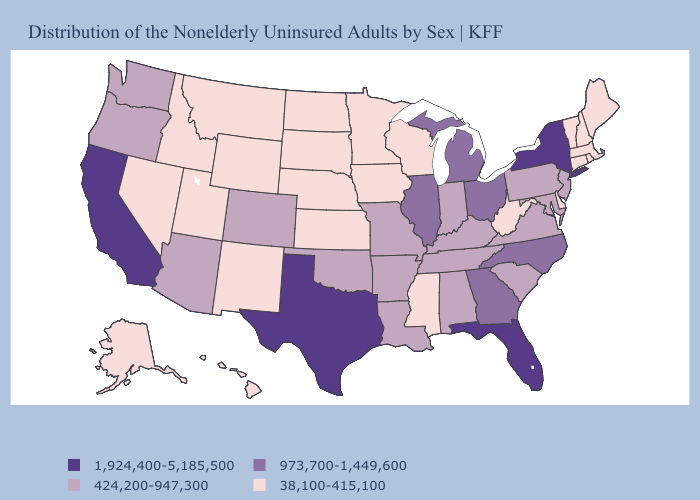Which states have the highest value in the USA?
Quick response, please. California, Florida, New York, Texas. Does Vermont have a lower value than New Hampshire?
Write a very short answer. No. Name the states that have a value in the range 38,100-415,100?
Keep it brief. Alaska, Connecticut, Delaware, Hawaii, Idaho, Iowa, Kansas, Maine, Massachusetts, Minnesota, Mississippi, Montana, Nebraska, Nevada, New Hampshire, New Mexico, North Dakota, Rhode Island, South Dakota, Utah, Vermont, West Virginia, Wisconsin, Wyoming. Does the first symbol in the legend represent the smallest category?
Be succinct. No. What is the value of Nebraska?
Be succinct. 38,100-415,100. Name the states that have a value in the range 424,200-947,300?
Keep it brief. Alabama, Arizona, Arkansas, Colorado, Indiana, Kentucky, Louisiana, Maryland, Missouri, New Jersey, Oklahoma, Oregon, Pennsylvania, South Carolina, Tennessee, Virginia, Washington. Does Michigan have the lowest value in the MidWest?
Be succinct. No. Among the states that border Missouri , does Kentucky have the highest value?
Concise answer only. No. Does Utah have the lowest value in the USA?
Quick response, please. Yes. Among the states that border Colorado , does Oklahoma have the lowest value?
Concise answer only. No. Among the states that border Louisiana , which have the highest value?
Quick response, please. Texas. Name the states that have a value in the range 424,200-947,300?
Concise answer only. Alabama, Arizona, Arkansas, Colorado, Indiana, Kentucky, Louisiana, Maryland, Missouri, New Jersey, Oklahoma, Oregon, Pennsylvania, South Carolina, Tennessee, Virginia, Washington. What is the value of Minnesota?
Keep it brief. 38,100-415,100. Name the states that have a value in the range 38,100-415,100?
Be succinct. Alaska, Connecticut, Delaware, Hawaii, Idaho, Iowa, Kansas, Maine, Massachusetts, Minnesota, Mississippi, Montana, Nebraska, Nevada, New Hampshire, New Mexico, North Dakota, Rhode Island, South Dakota, Utah, Vermont, West Virginia, Wisconsin, Wyoming. What is the value of South Carolina?
Give a very brief answer. 424,200-947,300. 